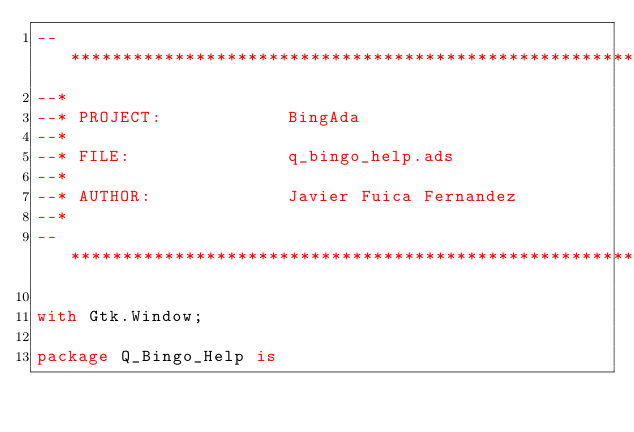<code> <loc_0><loc_0><loc_500><loc_500><_Ada_>--*****************************************************************************
--*
--* PROJECT:            BingAda
--*
--* FILE:               q_bingo_help.ads
--*
--* AUTHOR:             Javier Fuica Fernandez
--*
--*****************************************************************************

with Gtk.Window;

package Q_Bingo_Help is
</code> 